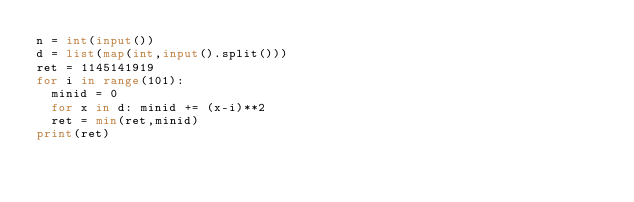Convert code to text. <code><loc_0><loc_0><loc_500><loc_500><_Python_>n = int(input())
d = list(map(int,input().split()))
ret = 1145141919
for i in range(101):
  minid = 0
  for x in d: minid += (x-i)**2
  ret = min(ret,minid)
print(ret)</code> 